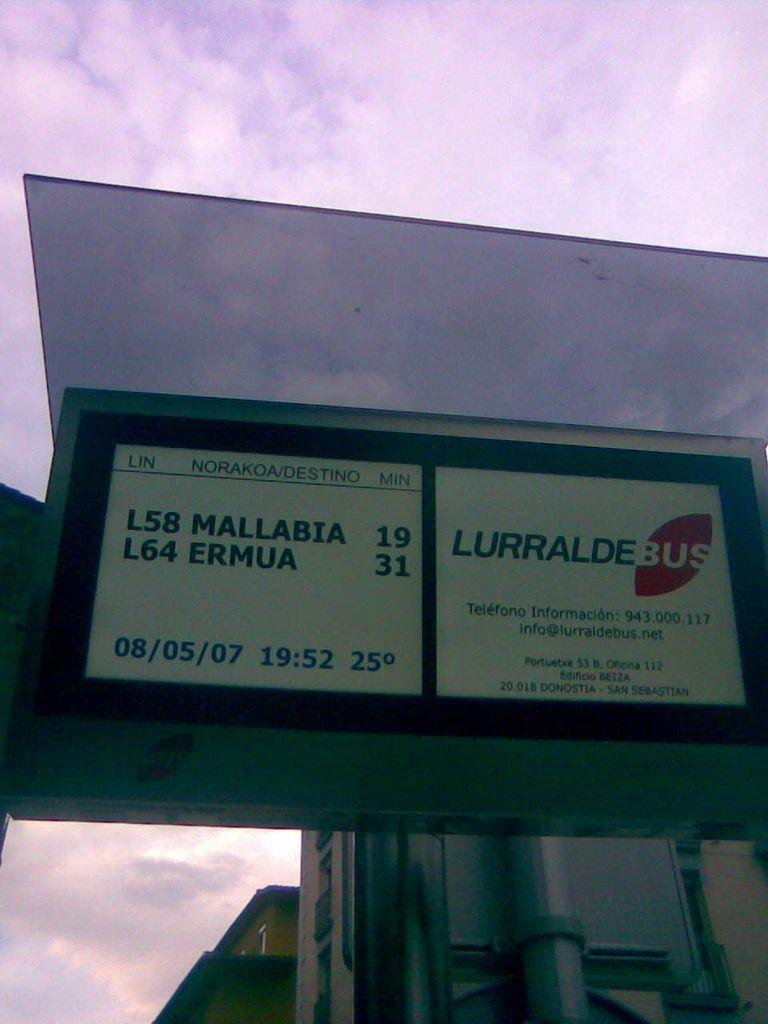What is the date on the sign?
Your answer should be very brief. 08/05/07. Who is the phone number?
Your response must be concise. 943.000.117. 